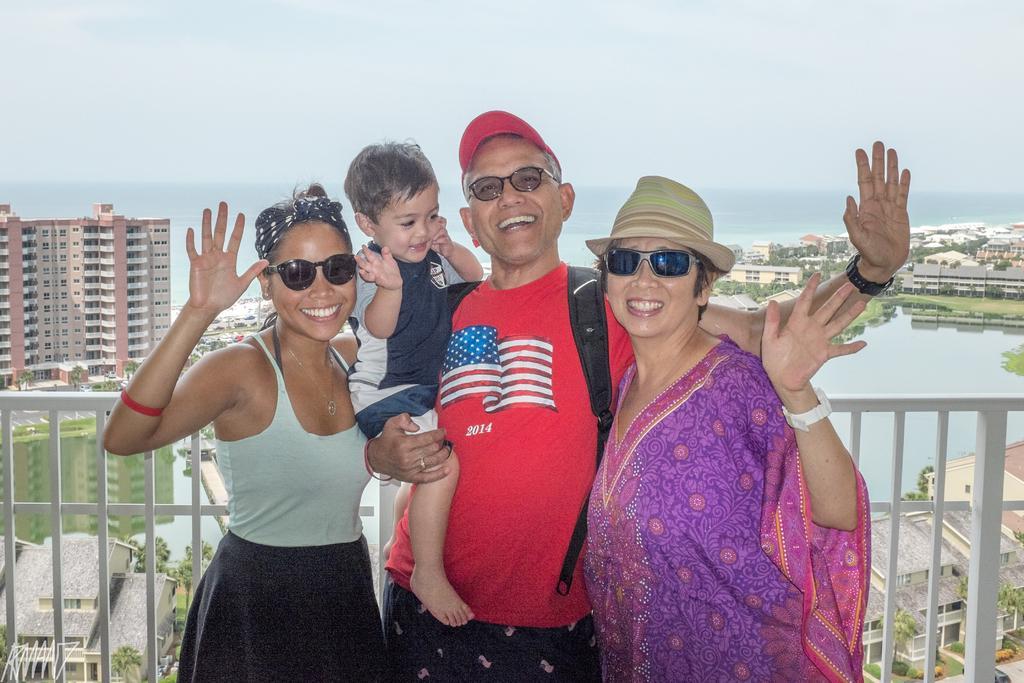How would you summarize this image in a sentence or two? In this image we can see a man, two women and a boy. The man is wearing red color t-shirt, carrying black bag and holding the boy in his hand. One woman is wearing a purple color dress and the other woman is wearing a white top with black skirt. The boy is wearing dark blue color t-shirt with shorts. Behind them, we can see white fencing. We can see buildings, tree and lake in the background. At the top of the image, we can see the sky which is in white color. 